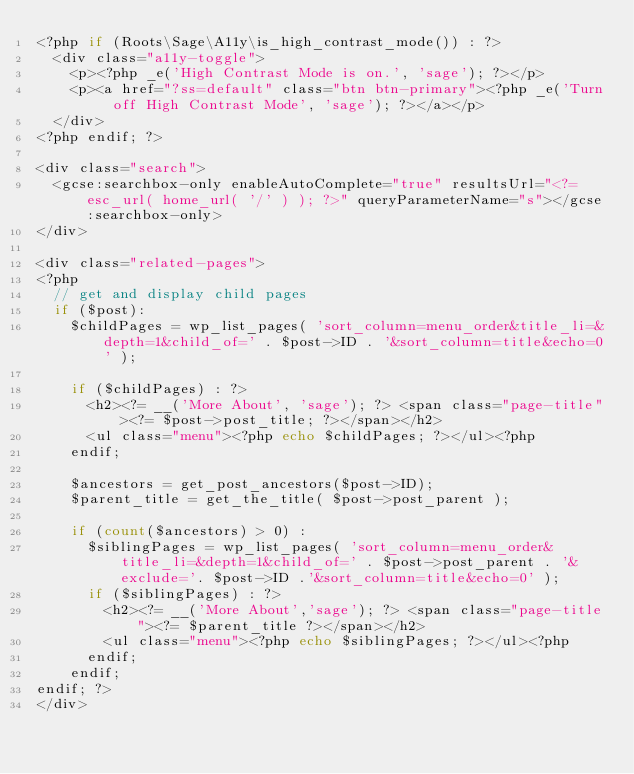<code> <loc_0><loc_0><loc_500><loc_500><_PHP_><?php if (Roots\Sage\A11y\is_high_contrast_mode()) : ?>
  <div class="a11y-toggle">
    <p><?php _e('High Contrast Mode is on.', 'sage'); ?></p>
    <p><a href="?ss=default" class="btn btn-primary"><?php _e('Turn off High Contrast Mode', 'sage'); ?></a></p>
  </div>
<?php endif; ?>

<div class="search">
  <gcse:searchbox-only enableAutoComplete="true" resultsUrl="<?= esc_url( home_url( '/' ) ); ?>" queryParameterName="s"></gcse:searchbox-only>
</div>

<div class="related-pages">
<?php
  // get and display child pages
  if ($post):
    $childPages = wp_list_pages( 'sort_column=menu_order&title_li=&depth=1&child_of=' . $post->ID . '&sort_column=title&echo=0' );

    if ($childPages) : ?>
      <h2><?= __('More About', 'sage'); ?> <span class="page-title"><?= $post->post_title; ?></span></h2>
      <ul class="menu"><?php echo $childPages; ?></ul><?php
    endif;

    $ancestors = get_post_ancestors($post->ID);
    $parent_title = get_the_title( $post->post_parent );

    if (count($ancestors) > 0) :
      $siblingPages = wp_list_pages( 'sort_column=menu_order&title_li=&depth=1&child_of=' . $post->post_parent . '&exclude='. $post->ID .'&sort_column=title&echo=0' );
      if ($siblingPages) : ?>
        <h2><?= __('More About','sage'); ?> <span class="page-title"><?= $parent_title ?></span></h2>
        <ul class="menu"><?php echo $siblingPages; ?></ul><?php
      endif;
    endif;
endif; ?>
</div>
</code> 